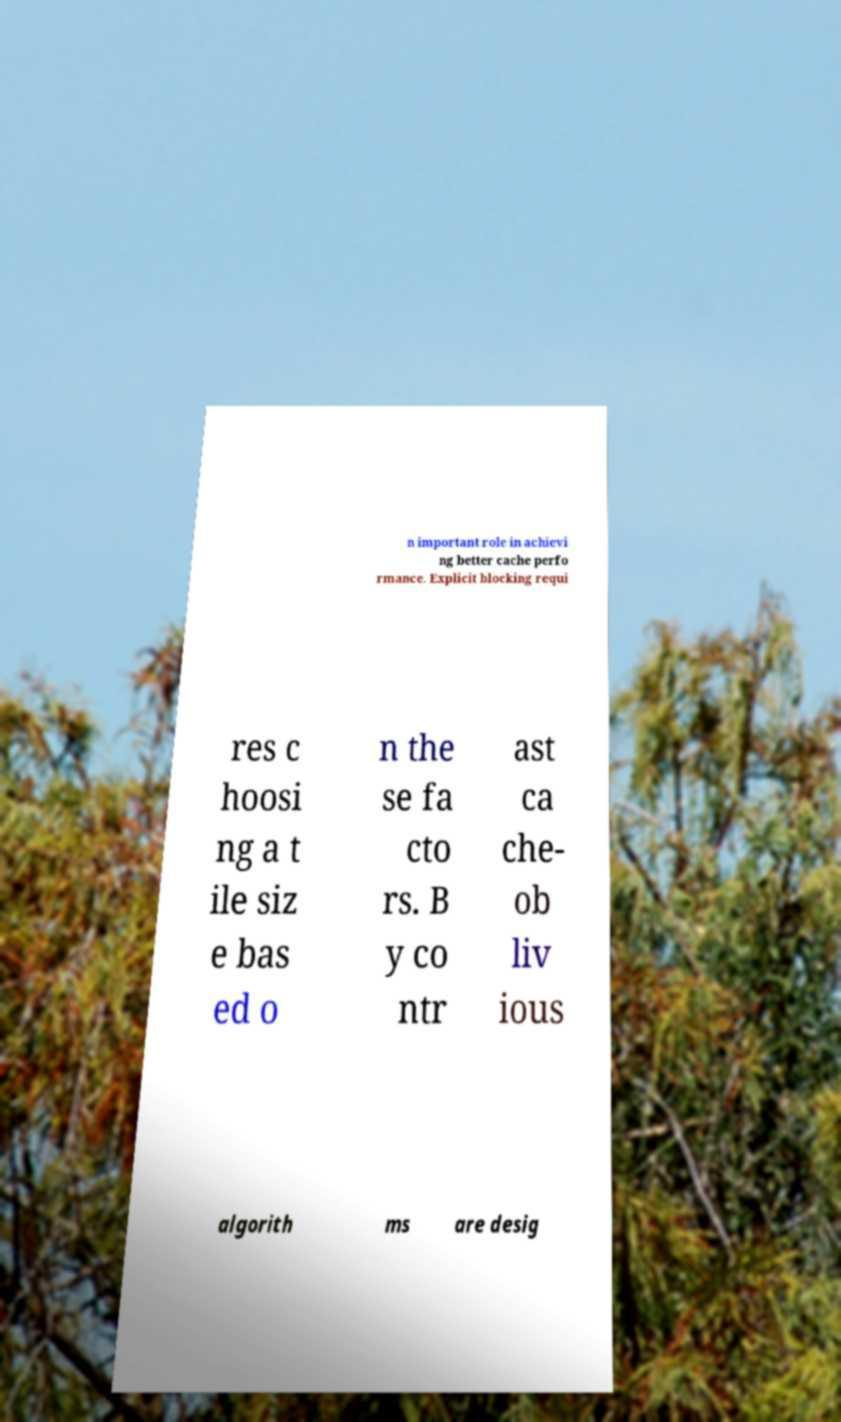Could you extract and type out the text from this image? n important role in achievi ng better cache perfo rmance. Explicit blocking requi res c hoosi ng a t ile siz e bas ed o n the se fa cto rs. B y co ntr ast ca che- ob liv ious algorith ms are desig 